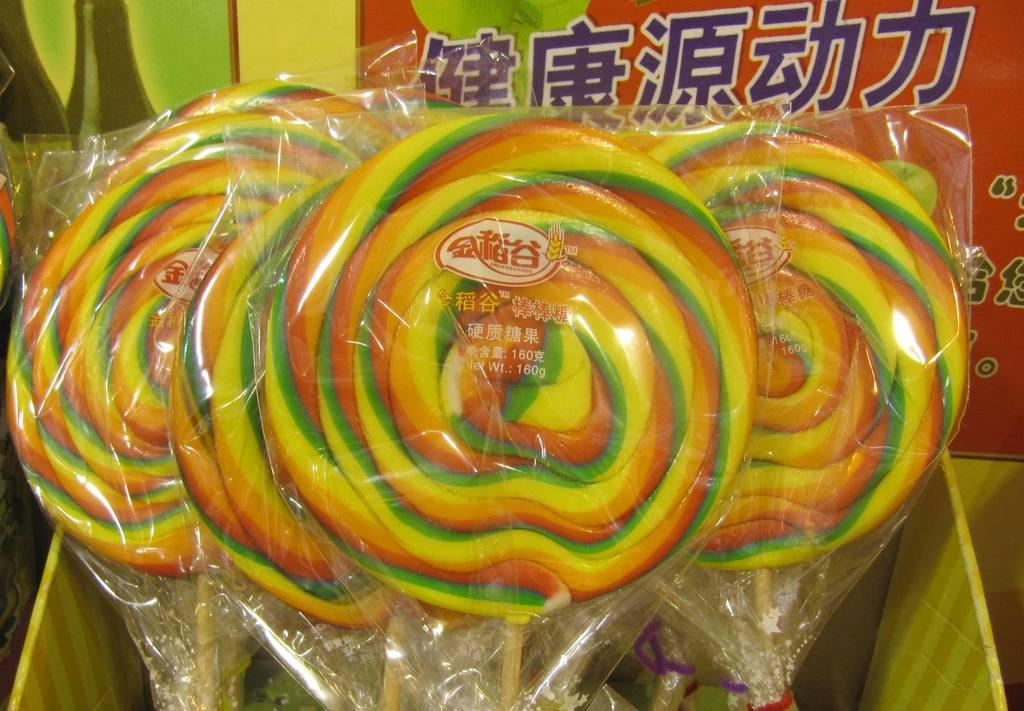What type of sweets can be seen in the image? There are candies in the image. How are the candies stored or contained in the image? The candies are kept in a box. What type of bird can be seen flying over the candies in the image? There is no bird present in the image; it only features candies in a box. 